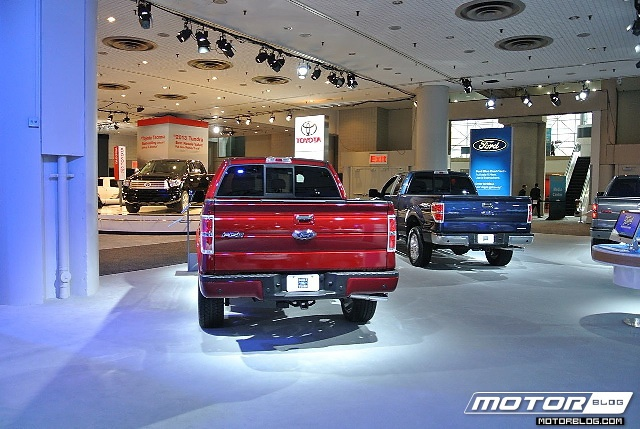Describe the objects in this image and their specific colors. I can see truck in blue, black, maroon, brown, and navy tones, truck in blue, black, navy, gray, and white tones, truck in blue, black, maroon, gray, and ivory tones, truck in blue, black, gray, and darkgray tones, and truck in blue, tan, black, lightyellow, and darkgray tones in this image. 